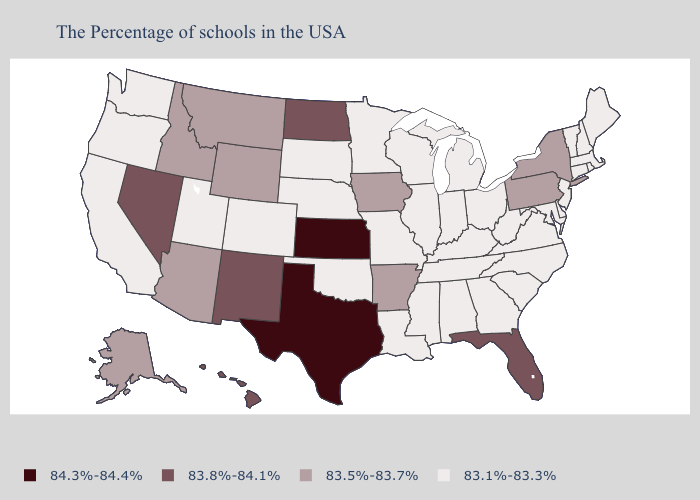Is the legend a continuous bar?
Short answer required. No. Among the states that border Wisconsin , does Minnesota have the highest value?
Write a very short answer. No. Among the states that border Montana , does Idaho have the highest value?
Short answer required. No. What is the value of Florida?
Short answer required. 83.8%-84.1%. Is the legend a continuous bar?
Quick response, please. No. Name the states that have a value in the range 83.1%-83.3%?
Short answer required. Maine, Massachusetts, Rhode Island, New Hampshire, Vermont, Connecticut, New Jersey, Delaware, Maryland, Virginia, North Carolina, South Carolina, West Virginia, Ohio, Georgia, Michigan, Kentucky, Indiana, Alabama, Tennessee, Wisconsin, Illinois, Mississippi, Louisiana, Missouri, Minnesota, Nebraska, Oklahoma, South Dakota, Colorado, Utah, California, Washington, Oregon. What is the value of Tennessee?
Write a very short answer. 83.1%-83.3%. What is the value of Michigan?
Concise answer only. 83.1%-83.3%. What is the lowest value in the USA?
Short answer required. 83.1%-83.3%. Name the states that have a value in the range 83.1%-83.3%?
Be succinct. Maine, Massachusetts, Rhode Island, New Hampshire, Vermont, Connecticut, New Jersey, Delaware, Maryland, Virginia, North Carolina, South Carolina, West Virginia, Ohio, Georgia, Michigan, Kentucky, Indiana, Alabama, Tennessee, Wisconsin, Illinois, Mississippi, Louisiana, Missouri, Minnesota, Nebraska, Oklahoma, South Dakota, Colorado, Utah, California, Washington, Oregon. Name the states that have a value in the range 83.5%-83.7%?
Answer briefly. New York, Pennsylvania, Arkansas, Iowa, Wyoming, Montana, Arizona, Idaho, Alaska. Which states have the lowest value in the USA?
Concise answer only. Maine, Massachusetts, Rhode Island, New Hampshire, Vermont, Connecticut, New Jersey, Delaware, Maryland, Virginia, North Carolina, South Carolina, West Virginia, Ohio, Georgia, Michigan, Kentucky, Indiana, Alabama, Tennessee, Wisconsin, Illinois, Mississippi, Louisiana, Missouri, Minnesota, Nebraska, Oklahoma, South Dakota, Colorado, Utah, California, Washington, Oregon. Name the states that have a value in the range 83.8%-84.1%?
Concise answer only. Florida, North Dakota, New Mexico, Nevada, Hawaii. What is the lowest value in the Northeast?
Write a very short answer. 83.1%-83.3%. What is the value of Iowa?
Concise answer only. 83.5%-83.7%. 